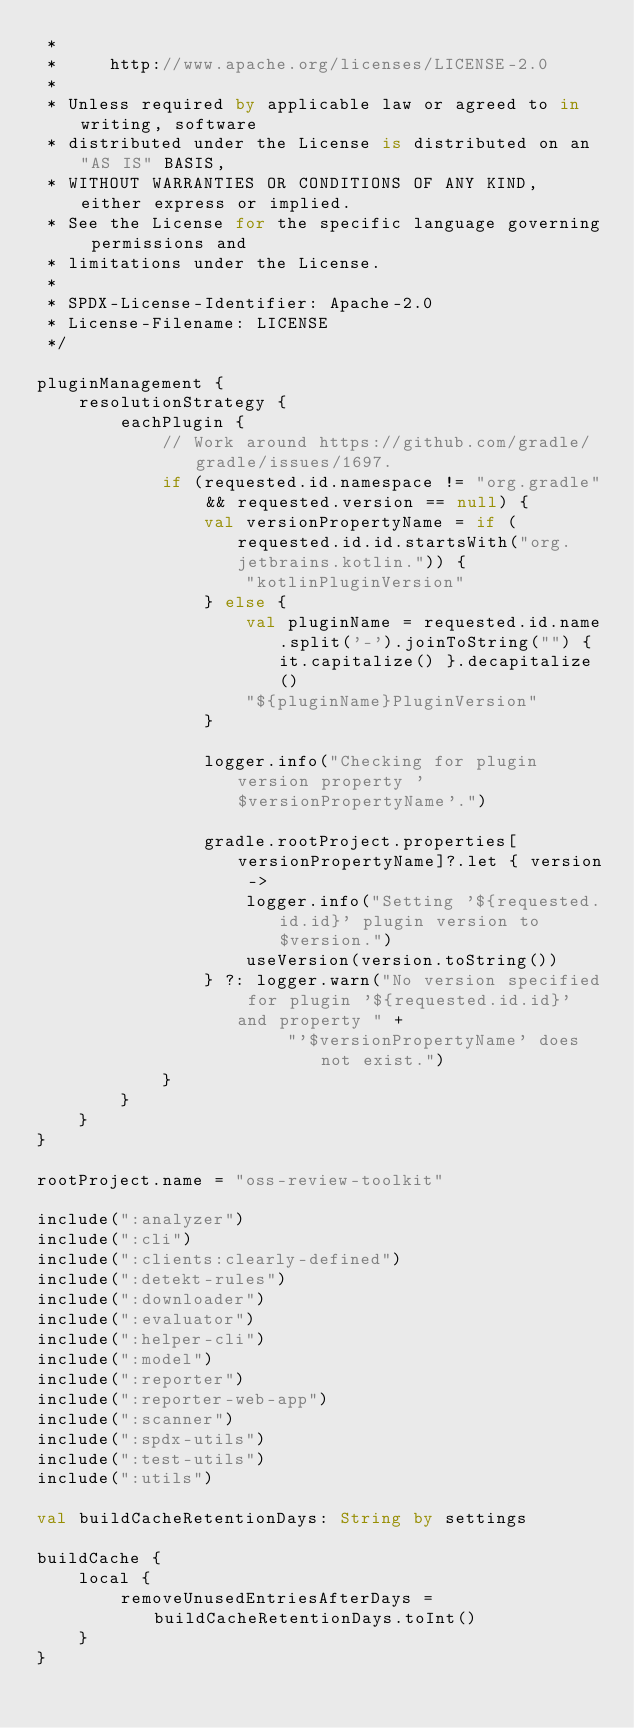Convert code to text. <code><loc_0><loc_0><loc_500><loc_500><_Kotlin_> *
 *     http://www.apache.org/licenses/LICENSE-2.0
 *
 * Unless required by applicable law or agreed to in writing, software
 * distributed under the License is distributed on an "AS IS" BASIS,
 * WITHOUT WARRANTIES OR CONDITIONS OF ANY KIND, either express or implied.
 * See the License for the specific language governing permissions and
 * limitations under the License.
 *
 * SPDX-License-Identifier: Apache-2.0
 * License-Filename: LICENSE
 */

pluginManagement {
    resolutionStrategy {
        eachPlugin {
            // Work around https://github.com/gradle/gradle/issues/1697.
            if (requested.id.namespace != "org.gradle" && requested.version == null) {
                val versionPropertyName = if (requested.id.id.startsWith("org.jetbrains.kotlin.")) {
                    "kotlinPluginVersion"
                } else {
                    val pluginName = requested.id.name.split('-').joinToString("") { it.capitalize() }.decapitalize()
                    "${pluginName}PluginVersion"
                }

                logger.info("Checking for plugin version property '$versionPropertyName'.")

                gradle.rootProject.properties[versionPropertyName]?.let { version ->
                    logger.info("Setting '${requested.id.id}' plugin version to $version.")
                    useVersion(version.toString())
                } ?: logger.warn("No version specified for plugin '${requested.id.id}' and property " +
                        "'$versionPropertyName' does not exist.")
            }
        }
    }
}

rootProject.name = "oss-review-toolkit"

include(":analyzer")
include(":cli")
include(":clients:clearly-defined")
include(":detekt-rules")
include(":downloader")
include(":evaluator")
include(":helper-cli")
include(":model")
include(":reporter")
include(":reporter-web-app")
include(":scanner")
include(":spdx-utils")
include(":test-utils")
include(":utils")

val buildCacheRetentionDays: String by settings

buildCache {
    local {
        removeUnusedEntriesAfterDays = buildCacheRetentionDays.toInt()
    }
}
</code> 